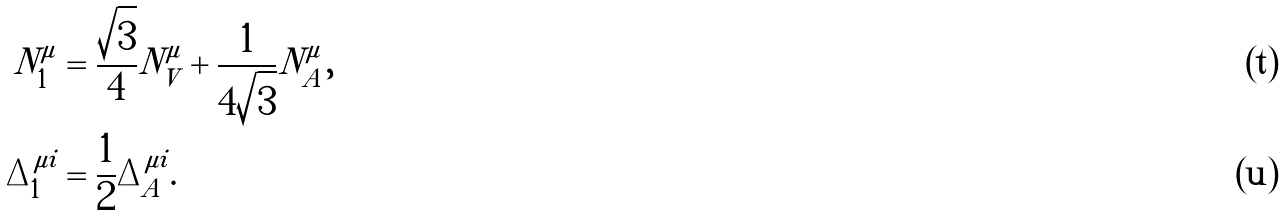<formula> <loc_0><loc_0><loc_500><loc_500>N _ { 1 } ^ { \mu } & = \frac { \sqrt { 3 } } { 4 } N _ { V } ^ { \mu } + \frac { 1 } { 4 \sqrt { 3 } } N _ { A } ^ { \mu } , \\ \Delta _ { 1 } ^ { \mu i } & = \frac { 1 } { 2 } \Delta _ { A } ^ { \mu i } .</formula> 